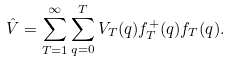<formula> <loc_0><loc_0><loc_500><loc_500>\hat { V } = \sum _ { T = 1 } ^ { \infty } \sum _ { q = 0 } ^ { T } V _ { T } ( q ) f ^ { + } _ { T } ( q ) f _ { T } ( q ) .</formula> 